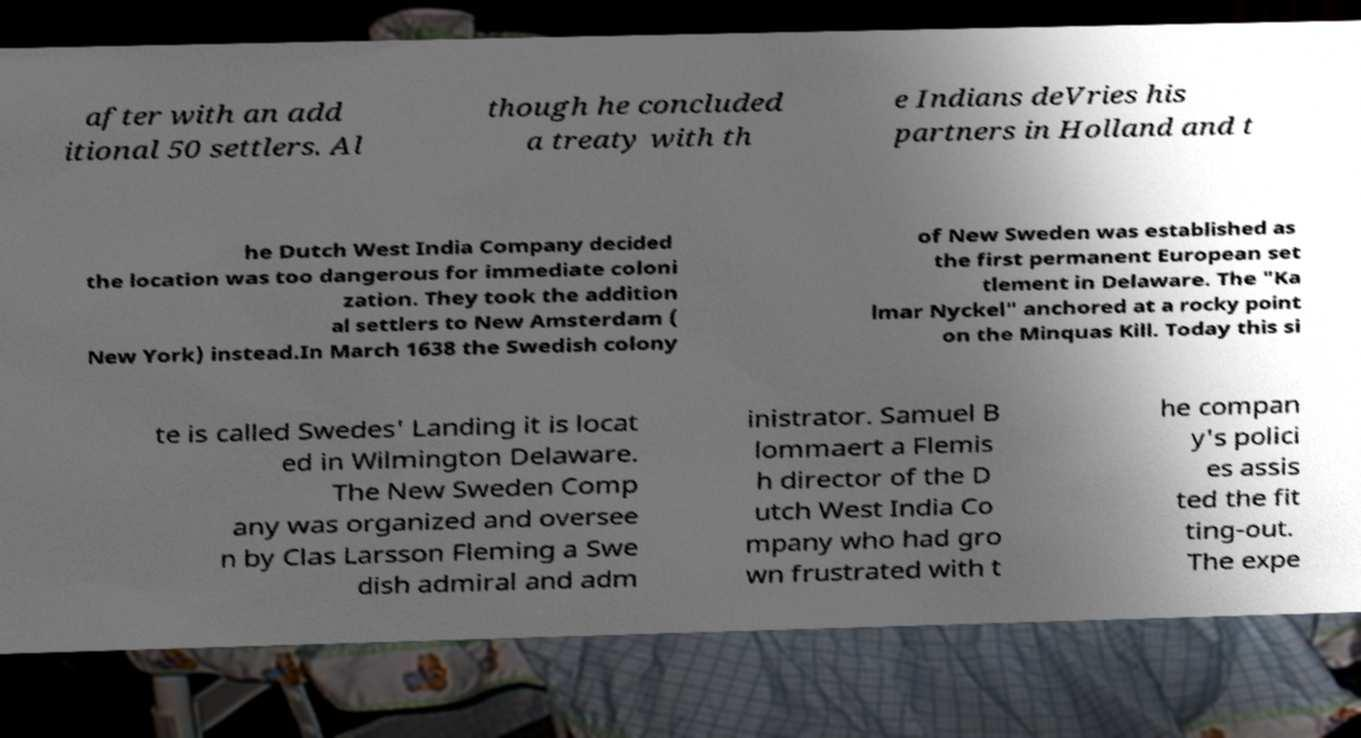Could you extract and type out the text from this image? after with an add itional 50 settlers. Al though he concluded a treaty with th e Indians deVries his partners in Holland and t he Dutch West India Company decided the location was too dangerous for immediate coloni zation. They took the addition al settlers to New Amsterdam ( New York) instead.In March 1638 the Swedish colony of New Sweden was established as the first permanent European set tlement in Delaware. The "Ka lmar Nyckel" anchored at a rocky point on the Minquas Kill. Today this si te is called Swedes' Landing it is locat ed in Wilmington Delaware. The New Sweden Comp any was organized and oversee n by Clas Larsson Fleming a Swe dish admiral and adm inistrator. Samuel B lommaert a Flemis h director of the D utch West India Co mpany who had gro wn frustrated with t he compan y's polici es assis ted the fit ting-out. The expe 